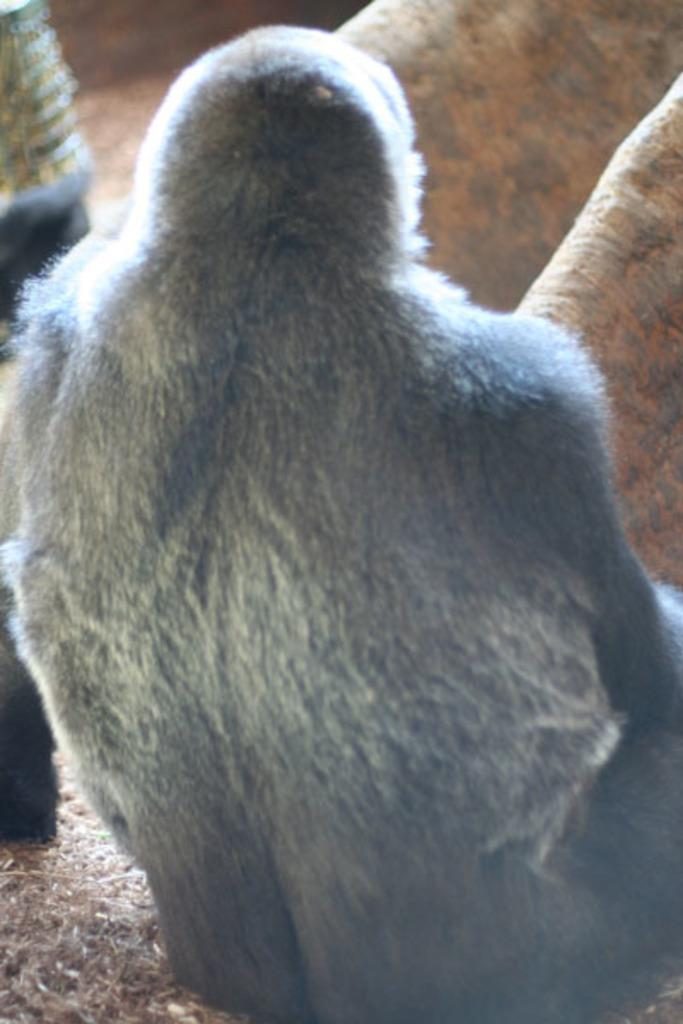What type of animal is in the image? There is a chimpanzee in the image. Where is the chimpanzee located? The chimpanzee is on the ground. Are there any other animals present in the image? Yes, there are other animals in the image. Can you tell me where the chimpanzee is taking a bath in the image? There is no indication of a bath or any water source in the image, so it cannot be determined where the chimpanzee might be taking a bath. 